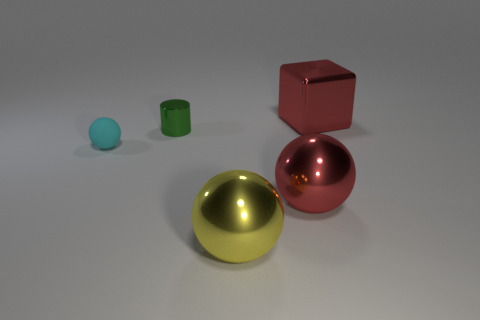Add 2 brown cylinders. How many objects exist? 7 Subtract all balls. How many objects are left? 2 Subtract all green rubber blocks. Subtract all tiny rubber spheres. How many objects are left? 4 Add 1 tiny cylinders. How many tiny cylinders are left? 2 Add 2 green objects. How many green objects exist? 3 Subtract 1 red blocks. How many objects are left? 4 